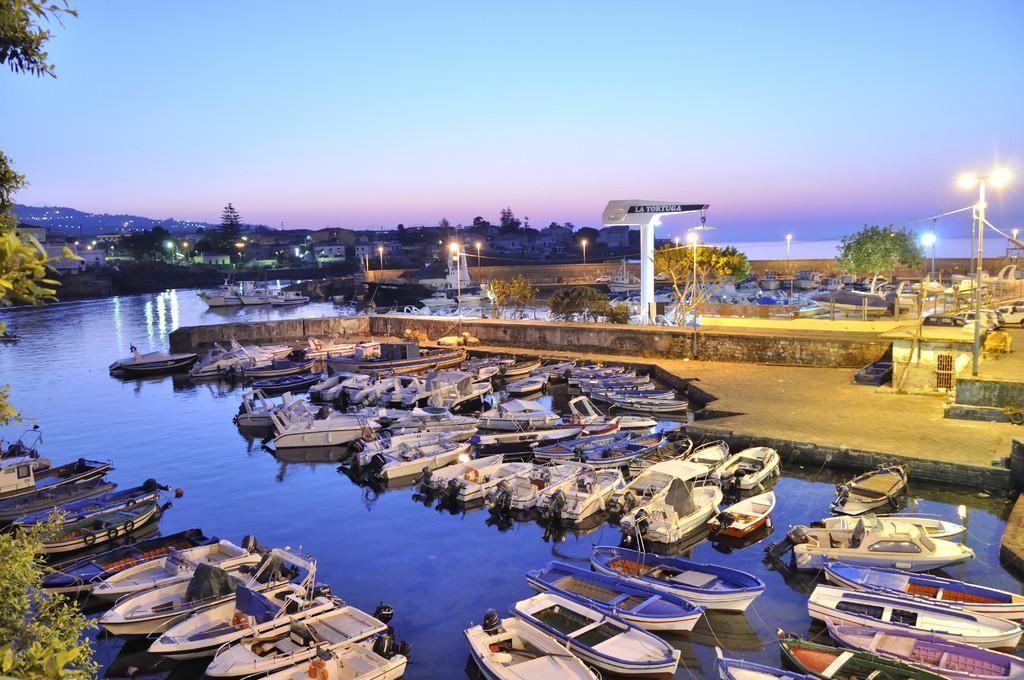Can you describe this image briefly? On the left side of this image there is a sea. I can see many boats on the water. In the background there are many light poles, trees and buildings. At the top of the image I can see the sky. 